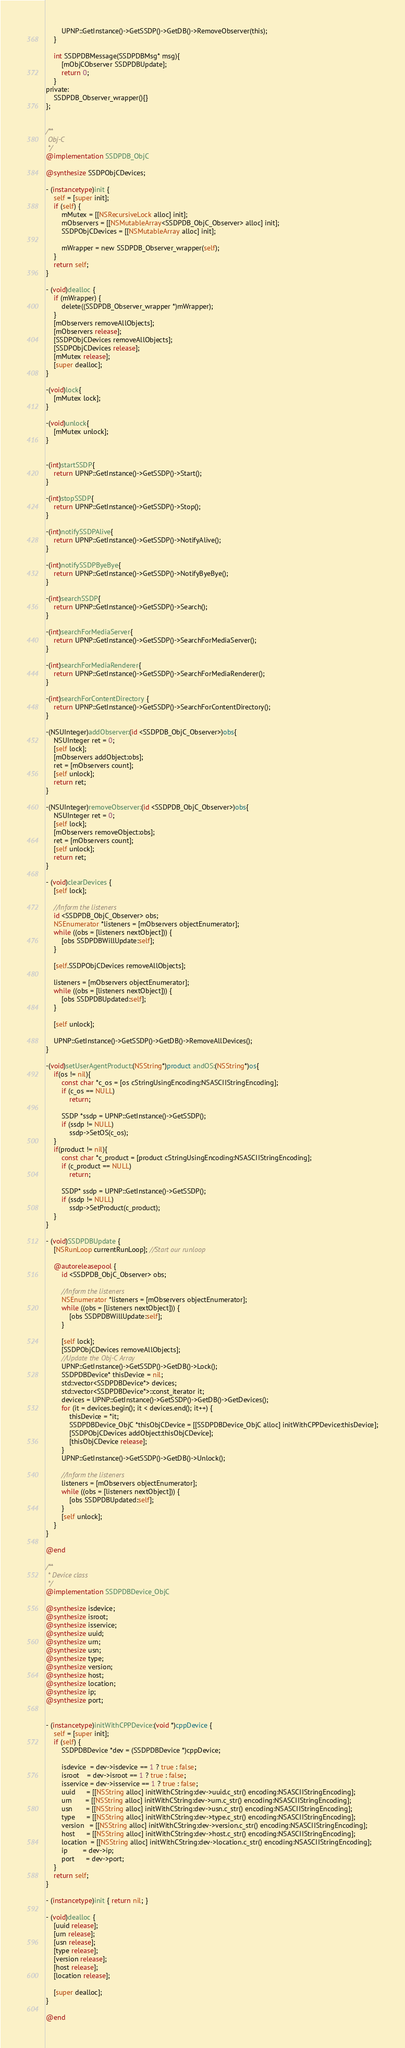Convert code to text. <code><loc_0><loc_0><loc_500><loc_500><_ObjectiveC_>        UPNP::GetInstance()->GetSSDP()->GetDB()->RemoveObserver(this);
    }

    int SSDPDBMessage(SSDPDBMsg* msg){
        [mObjCObserver SSDPDBUpdate];
        return 0;
    }
private:
    SSDPDB_Observer_wrapper(){}
};


/**
 Obj-C
 */
@implementation SSDPDB_ObjC

@synthesize SSDPObjCDevices;

- (instancetype)init {
    self = [super init];
    if (self) {
        mMutex = [[NSRecursiveLock alloc] init];
        mObservers = [[NSMutableArray<SSDPDB_ObjC_Observer> alloc] init];
        SSDPObjCDevices = [[NSMutableArray alloc] init];

        mWrapper = new SSDPDB_Observer_wrapper(self);
    }
    return self;
}

- (void)dealloc {
    if (mWrapper) {
        delete((SSDPDB_Observer_wrapper *)mWrapper);
    }
    [mObservers removeAllObjects];
    [mObservers release];
    [SSDPObjCDevices removeAllObjects];
    [SSDPObjCDevices release];
    [mMutex release];
    [super dealloc];
}

-(void)lock{
    [mMutex lock];
}

-(void)unlock{
    [mMutex unlock];
}


-(int)startSSDP{
    return UPNP::GetInstance()->GetSSDP()->Start();
}

-(int)stopSSDP{
    return UPNP::GetInstance()->GetSSDP()->Stop();
}

-(int)notifySSDPAlive{
    return UPNP::GetInstance()->GetSSDP()->NotifyAlive();
}

-(int)notifySSDPByeBye{
    return UPNP::GetInstance()->GetSSDP()->NotifyByeBye();
}

-(int)searchSSDP{
    return UPNP::GetInstance()->GetSSDP()->Search();
}

-(int)searchForMediaServer{
    return UPNP::GetInstance()->GetSSDP()->SearchForMediaServer();
}

-(int)searchForMediaRenderer{
    return UPNP::GetInstance()->GetSSDP()->SearchForMediaRenderer();
}

-(int)searchForContentDirectory {
    return UPNP::GetInstance()->GetSSDP()->SearchForContentDirectory();
}

-(NSUInteger)addObserver:(id <SSDPDB_ObjC_Observer>)obs{
    NSUInteger ret = 0;
    [self lock];
    [mObservers addObject:obs];
    ret = [mObservers count];
    [self unlock];
    return ret;
}

-(NSUInteger)removeObserver:(id <SSDPDB_ObjC_Observer>)obs{
    NSUInteger ret = 0;
    [self lock];
    [mObservers removeObject:obs];
    ret = [mObservers count];
    [self unlock];
    return ret;
}

- (void)clearDevices {
    [self lock];

    //Inform the listeners
    id <SSDPDB_ObjC_Observer> obs;
    NSEnumerator *listeners = [mObservers objectEnumerator];
    while ((obs = [listeners nextObject])) {
        [obs SSDPDBWillUpdate:self];
    }

    [self.SSDPObjCDevices removeAllObjects];

    listeners = [mObservers objectEnumerator];
    while ((obs = [listeners nextObject])) {
        [obs SSDPDBUpdated:self];
    }

    [self unlock];

    UPNP::GetInstance()->GetSSDP()->GetDB()->RemoveAllDevices();
}

-(void)setUserAgentProduct:(NSString*)product andOS:(NSString*)os{
    if(os != nil){
        const char *c_os = [os cStringUsingEncoding:NSASCIIStringEncoding];
        if (c_os == NULL)
            return;

        SSDP *ssdp = UPNP::GetInstance()->GetSSDP();
        if (ssdp != NULL)
            ssdp->SetOS(c_os);
    }
    if(product != nil){
        const char *c_product = [product cStringUsingEncoding:NSASCIIStringEncoding];
        if (c_product == NULL)
            return;

        SSDP* ssdp = UPNP::GetInstance()->GetSSDP();
        if (ssdp != NULL)
            ssdp->SetProduct(c_product);
    }
}

- (void)SSDPDBUpdate {
    [NSRunLoop currentRunLoop]; //Start our runloop

    @autoreleasepool {
        id <SSDPDB_ObjC_Observer> obs;

        //Inform the listeners
        NSEnumerator *listeners = [mObservers objectEnumerator];
        while ((obs = [listeners nextObject])) {
            [obs SSDPDBWillUpdate:self];
        }

        [self lock];
        [SSDPObjCDevices removeAllObjects];
        //Update the Obj-C Array
        UPNP::GetInstance()->GetSSDP()->GetDB()->Lock();
        SSDPDBDevice* thisDevice = nil;
        std::vector<SSDPDBDevice*> devices;
        std::vector<SSDPDBDevice*>::const_iterator it;
        devices = UPNP::GetInstance()->GetSSDP()->GetDB()->GetDevices();
        for (it = devices.begin(); it < devices.end(); it++) {
            thisDevice = *it;
            SSDPDBDevice_ObjC *thisObjCDevice = [[SSDPDBDevice_ObjC alloc] initWithCPPDevice:thisDevice];
            [SSDPObjCDevices addObject:thisObjCDevice];
            [thisObjCDevice release];
        }
        UPNP::GetInstance()->GetSSDP()->GetDB()->Unlock();

        //Inform the listeners
        listeners = [mObservers objectEnumerator];
        while ((obs = [listeners nextObject])) {
            [obs SSDPDBUpdated:self];
        }
        [self unlock];
    }
}

@end

/**
 * Device class
 */
@implementation SSDPDBDevice_ObjC

@synthesize isdevice;
@synthesize isroot;
@synthesize isservice;
@synthesize uuid;
@synthesize urn;
@synthesize usn;
@synthesize type;
@synthesize version;
@synthesize host;
@synthesize location;
@synthesize ip;
@synthesize port;


- (instancetype)initWithCPPDevice:(void *)cppDevice {
    self = [super init];
    if (self) {
        SSDPDBDevice *dev = (SSDPDBDevice *)cppDevice;

        isdevice  = dev->isdevice == 1 ? true : false;
        isroot    = dev->isroot == 1 ? true : false;
        isservice = dev->isservice == 1 ? true : false;
        uuid      = [[NSString alloc] initWithCString:dev->uuid.c_str() encoding:NSASCIIStringEncoding];
        urn       = [[NSString alloc] initWithCString:dev->urn.c_str() encoding:NSASCIIStringEncoding];
        usn       = [[NSString alloc] initWithCString:dev->usn.c_str() encoding:NSASCIIStringEncoding];
        type      = [[NSString alloc] initWithCString:dev->type.c_str() encoding:NSASCIIStringEncoding];
        version   = [[NSString alloc] initWithCString:dev->version.c_str() encoding:NSASCIIStringEncoding];
        host      = [[NSString alloc] initWithCString:dev->host.c_str() encoding:NSASCIIStringEncoding];
        location  = [[NSString alloc] initWithCString:dev->location.c_str() encoding:NSASCIIStringEncoding];
        ip        = dev->ip;
        port      = dev->port;
    }
    return self;
}

- (instancetype)init { return nil; }

- (void)dealloc {
    [uuid release];
    [urn release];
    [usn release];
    [type release];
    [version release];
    [host release];
    [location release];

    [super dealloc];
}

@end
</code> 